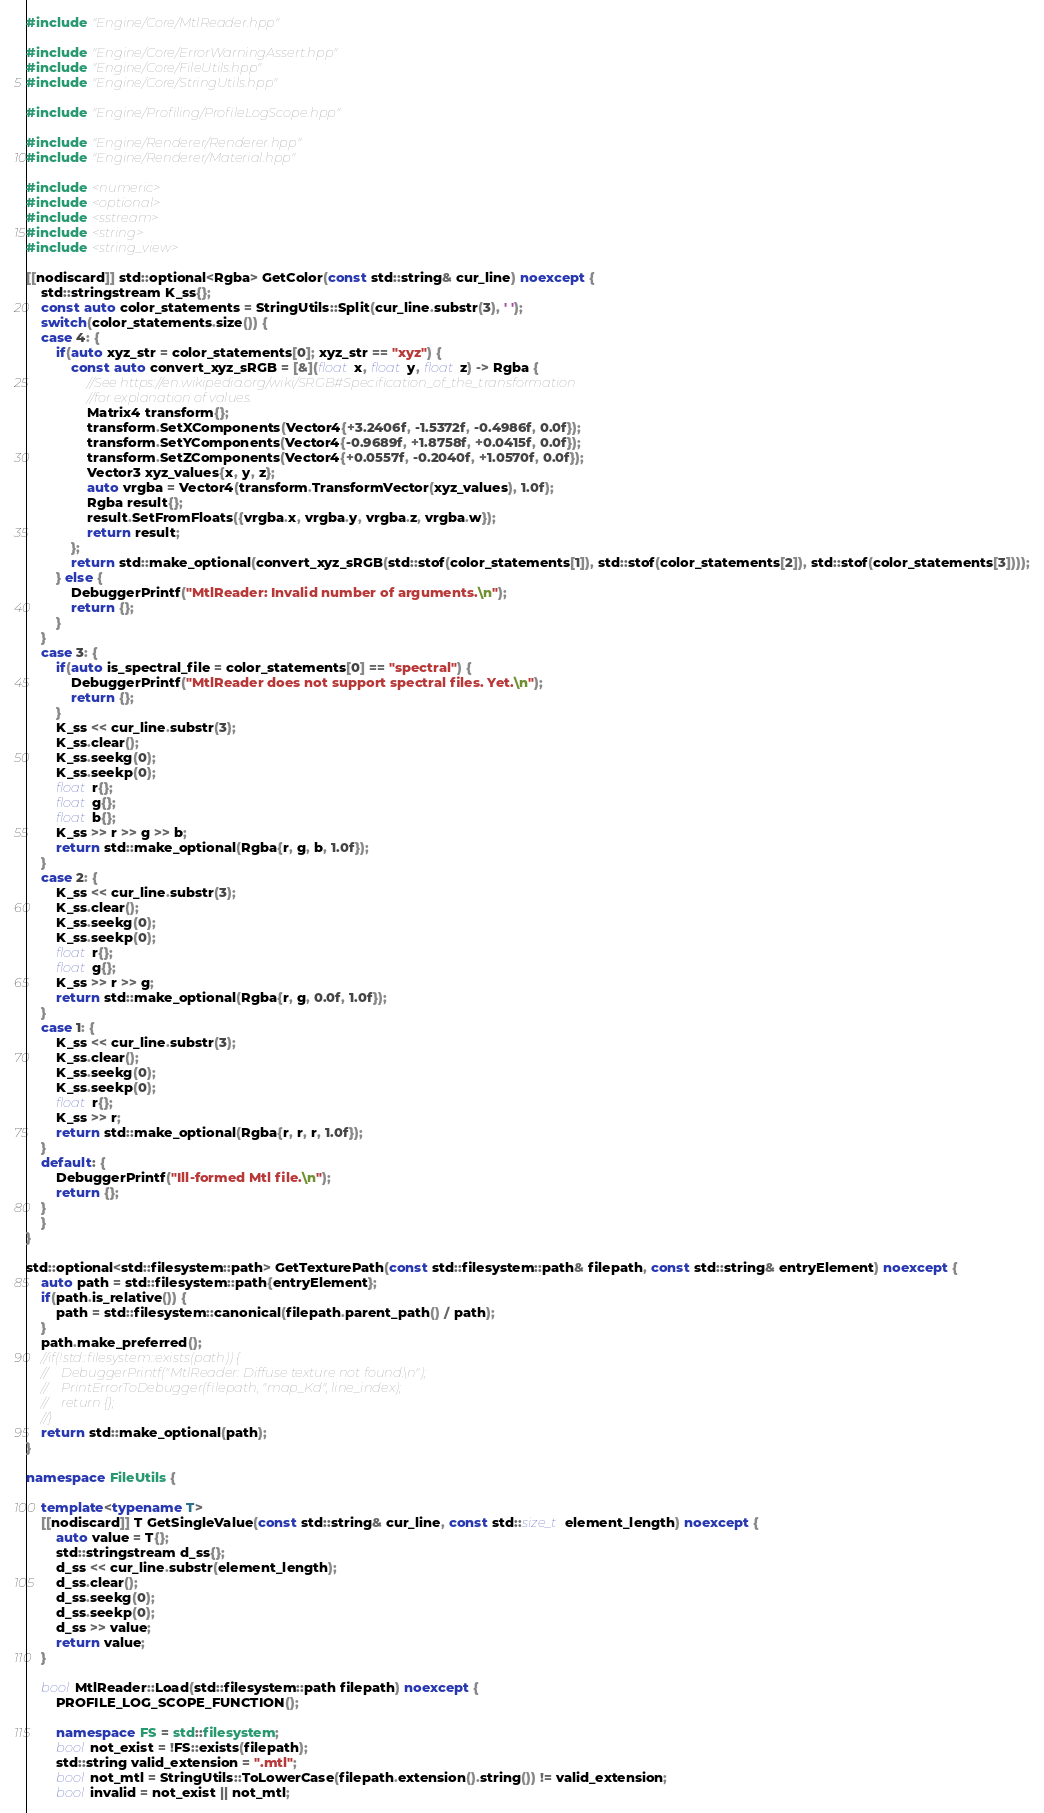Convert code to text. <code><loc_0><loc_0><loc_500><loc_500><_C++_>#include "Engine/Core/MtlReader.hpp"

#include "Engine/Core/ErrorWarningAssert.hpp"
#include "Engine/Core/FileUtils.hpp"
#include "Engine/Core/StringUtils.hpp"

#include "Engine/Profiling/ProfileLogScope.hpp"

#include "Engine/Renderer/Renderer.hpp"
#include "Engine/Renderer/Material.hpp"

#include <numeric>
#include <optional>
#include <sstream>
#include <string>
#include <string_view>

[[nodiscard]] std::optional<Rgba> GetColor(const std::string& cur_line) noexcept {
    std::stringstream K_ss{};
    const auto color_statements = StringUtils::Split(cur_line.substr(3), ' ');
    switch(color_statements.size()) {
    case 4: {
        if(auto xyz_str = color_statements[0]; xyz_str == "xyz") {
            const auto convert_xyz_sRGB = [&](float x, float y, float z) -> Rgba {
                //See https://en.wikipedia.org/wiki/SRGB#Specification_of_the_transformation
                //for explanation of values.
                Matrix4 transform{};
                transform.SetXComponents(Vector4{+3.2406f, -1.5372f, -0.4986f, 0.0f});
                transform.SetYComponents(Vector4{-0.9689f, +1.8758f, +0.0415f, 0.0f});
                transform.SetZComponents(Vector4{+0.0557f, -0.2040f, +1.0570f, 0.0f});
                Vector3 xyz_values{x, y, z};
                auto vrgba = Vector4(transform.TransformVector(xyz_values), 1.0f);
                Rgba result{};
                result.SetFromFloats({vrgba.x, vrgba.y, vrgba.z, vrgba.w});
                return result;
            };
            return std::make_optional(convert_xyz_sRGB(std::stof(color_statements[1]), std::stof(color_statements[2]), std::stof(color_statements[3])));
        } else {
            DebuggerPrintf("MtlReader: Invalid number of arguments.\n");
            return {};
        }
    }
    case 3: {
        if(auto is_spectral_file = color_statements[0] == "spectral") {
            DebuggerPrintf("MtlReader does not support spectral files. Yet.\n");
            return {};
        }
        K_ss << cur_line.substr(3);
        K_ss.clear();
        K_ss.seekg(0);
        K_ss.seekp(0);
        float r{};
        float g{};
        float b{};
        K_ss >> r >> g >> b;
        return std::make_optional(Rgba{r, g, b, 1.0f});
    }
    case 2: {
        K_ss << cur_line.substr(3);
        K_ss.clear();
        K_ss.seekg(0);
        K_ss.seekp(0);
        float r{};
        float g{};
        K_ss >> r >> g;
        return std::make_optional(Rgba{r, g, 0.0f, 1.0f});
    }
    case 1: {
        K_ss << cur_line.substr(3);
        K_ss.clear();
        K_ss.seekg(0);
        K_ss.seekp(0);
        float r{};
        K_ss >> r;
        return std::make_optional(Rgba{r, r, r, 1.0f});
    }
    default: {
        DebuggerPrintf("Ill-formed Mtl file.\n");
        return {};
    }
    }
}

std::optional<std::filesystem::path> GetTexturePath(const std::filesystem::path& filepath, const std::string& entryElement) noexcept {
    auto path = std::filesystem::path{entryElement};
    if(path.is_relative()) {
        path = std::filesystem::canonical(filepath.parent_path() / path);
    }
    path.make_preferred();
    //if(!std::filesystem::exists(path)) {
    //    DebuggerPrintf("MtlReader: Diffuse texture not found.\n");
    //    PrintErrorToDebugger(filepath, "map_Kd", line_index);
    //    return {};
    //}
    return std::make_optional(path);
}

namespace FileUtils {

    template<typename T>
    [[nodiscard]] T GetSingleValue(const std::string& cur_line, const std::size_t element_length) noexcept {
        auto value = T{};
        std::stringstream d_ss{};
        d_ss << cur_line.substr(element_length);
        d_ss.clear();
        d_ss.seekg(0);
        d_ss.seekp(0);
        d_ss >> value;
        return value;
    }

    bool MtlReader::Load(std::filesystem::path filepath) noexcept {
        PROFILE_LOG_SCOPE_FUNCTION();

        namespace FS = std::filesystem;
        bool not_exist = !FS::exists(filepath);
        std::string valid_extension = ".mtl";
        bool not_mtl = StringUtils::ToLowerCase(filepath.extension().string()) != valid_extension;
        bool invalid = not_exist || not_mtl;</code> 